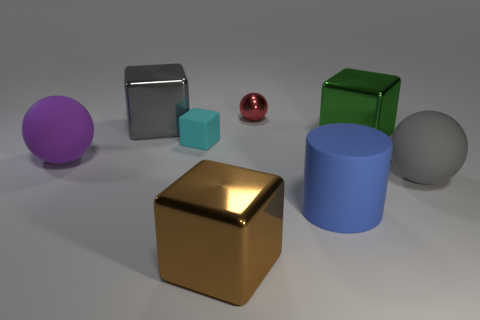Add 1 big green metallic objects. How many objects exist? 9 Subtract all spheres. How many objects are left? 5 Add 5 yellow matte objects. How many yellow matte objects exist? 5 Subtract 0 yellow cylinders. How many objects are left? 8 Subtract all yellow spheres. Subtract all shiny blocks. How many objects are left? 5 Add 2 metal things. How many metal things are left? 6 